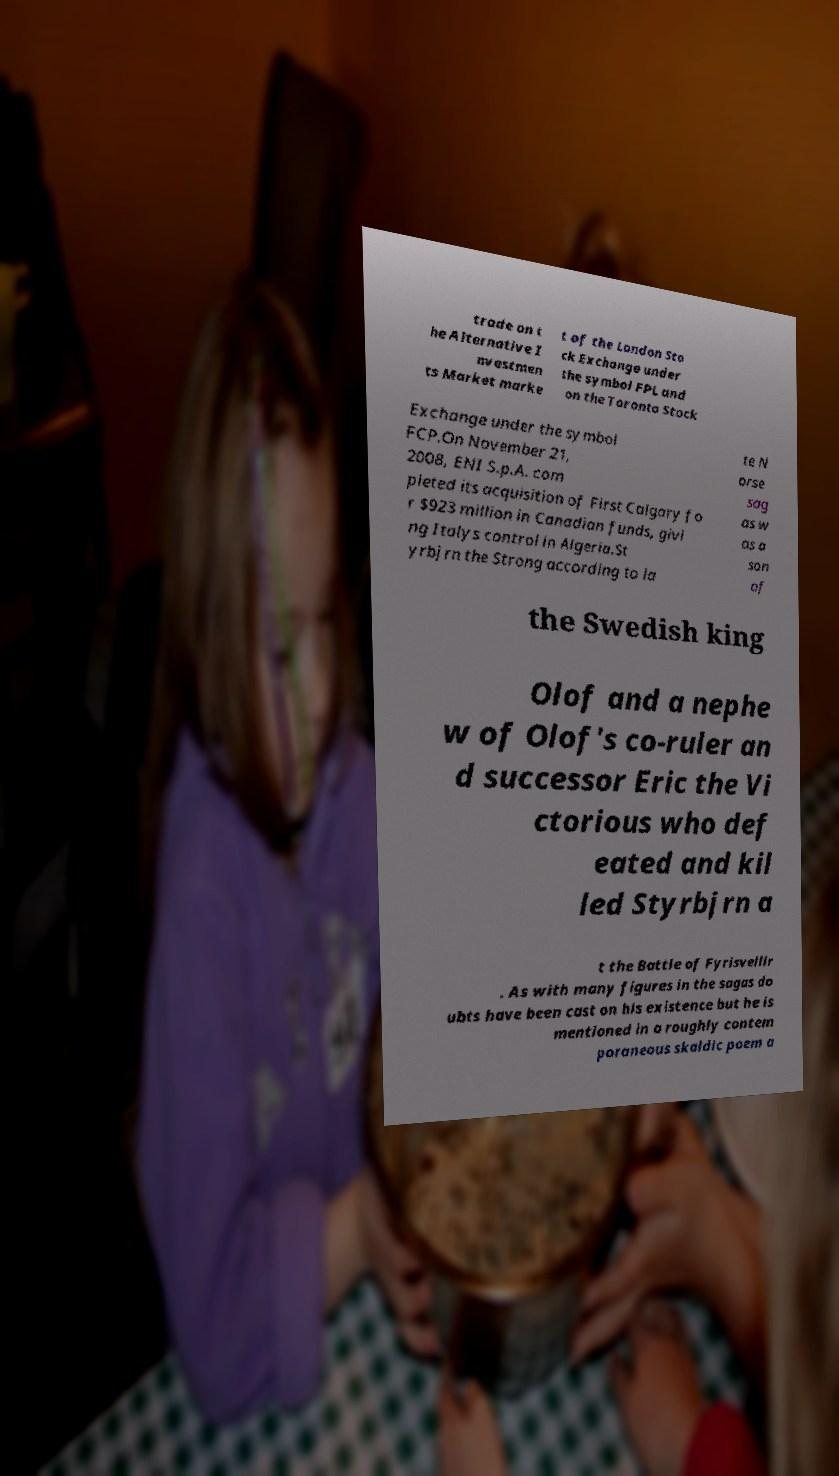Could you assist in decoding the text presented in this image and type it out clearly? trade on t he Alternative I nvestmen ts Market marke t of the London Sto ck Exchange under the symbol FPL and on the Toronto Stock Exchange under the symbol FCP.On November 21, 2008, ENI S.p.A. com pleted its acquisition of First Calgary fo r $923 million in Canadian funds, givi ng Italys control in Algeria.St yrbjrn the Strong according to la te N orse sag as w as a son of the Swedish king Olof and a nephe w of Olof's co-ruler an d successor Eric the Vi ctorious who def eated and kil led Styrbjrn a t the Battle of Fyrisvellir . As with many figures in the sagas do ubts have been cast on his existence but he is mentioned in a roughly contem poraneous skaldic poem a 